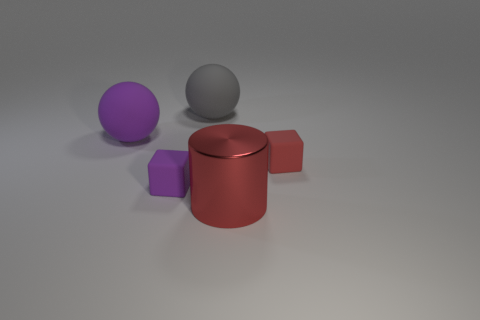Are there any other large cylinders of the same color as the metallic cylinder?
Provide a short and direct response. No. How big is the gray rubber sphere?
Give a very brief answer. Large. What number of objects are purple spheres or objects that are right of the purple rubber ball?
Offer a terse response. 5. What number of shiny cylinders are in front of the red object that is in front of the tiny cube on the right side of the tiny purple matte object?
Provide a succinct answer. 0. What material is the other small thing that is the same color as the metal object?
Your response must be concise. Rubber. How many gray rubber spheres are there?
Offer a very short reply. 1. There is a cube to the right of the red metal thing; is its size the same as the large red object?
Provide a succinct answer. No. How many matte things are balls or tiny green spheres?
Your response must be concise. 2. What number of purple matte objects are in front of the purple object that is behind the red block?
Offer a very short reply. 1. The large object that is to the right of the small purple matte thing and behind the tiny purple object has what shape?
Offer a terse response. Sphere. 